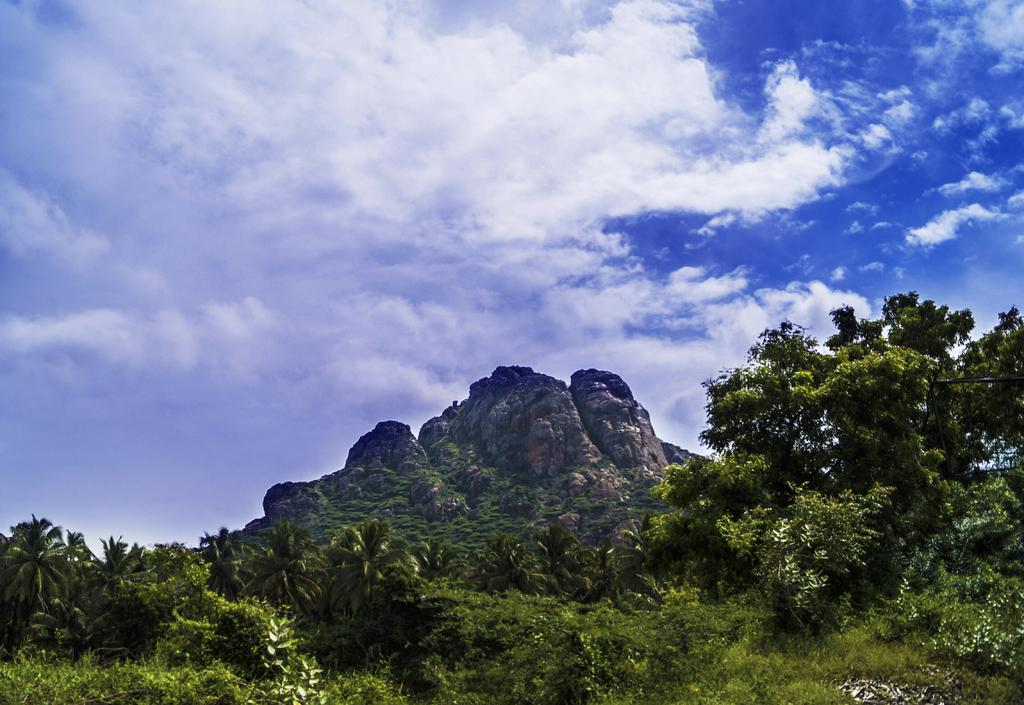What type of vegetation can be seen in the image? There is grass, plants, and trees in the image. What is the terrain like in the image? There is a hill in the image. What is visible in the background of the image? There is a sky visible in the background of the image. What can be seen in the sky? There are clouds in the sky. How many grapes are hanging from the trees in the image? There are no grapes present in the image; it features trees without any visible fruit. What type of comfort can be found in the image? The image does not depict any objects or elements that provide comfort. 